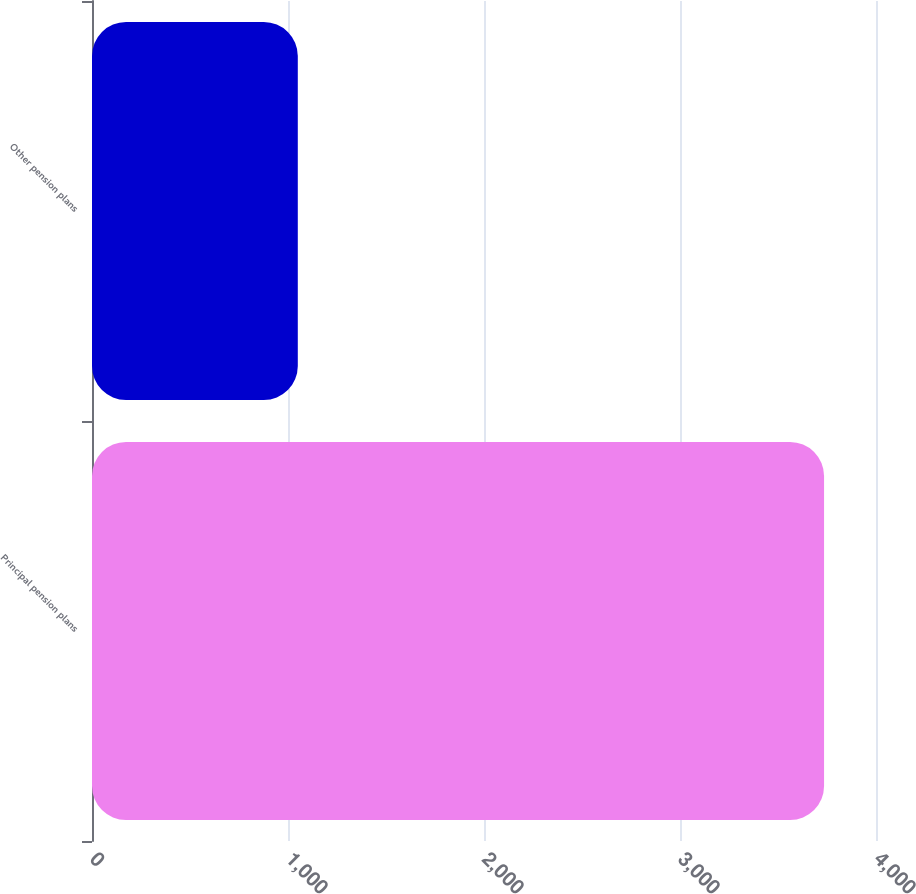<chart> <loc_0><loc_0><loc_500><loc_500><bar_chart><fcel>Principal pension plans<fcel>Other pension plans<nl><fcel>3735<fcel>1050<nl></chart> 